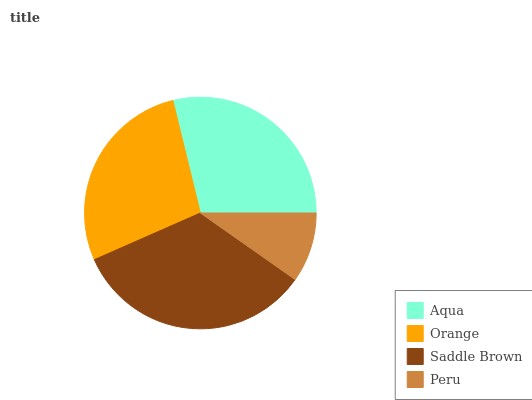Is Peru the minimum?
Answer yes or no. Yes. Is Saddle Brown the maximum?
Answer yes or no. Yes. Is Orange the minimum?
Answer yes or no. No. Is Orange the maximum?
Answer yes or no. No. Is Aqua greater than Orange?
Answer yes or no. Yes. Is Orange less than Aqua?
Answer yes or no. Yes. Is Orange greater than Aqua?
Answer yes or no. No. Is Aqua less than Orange?
Answer yes or no. No. Is Aqua the high median?
Answer yes or no. Yes. Is Orange the low median?
Answer yes or no. Yes. Is Saddle Brown the high median?
Answer yes or no. No. Is Aqua the low median?
Answer yes or no. No. 